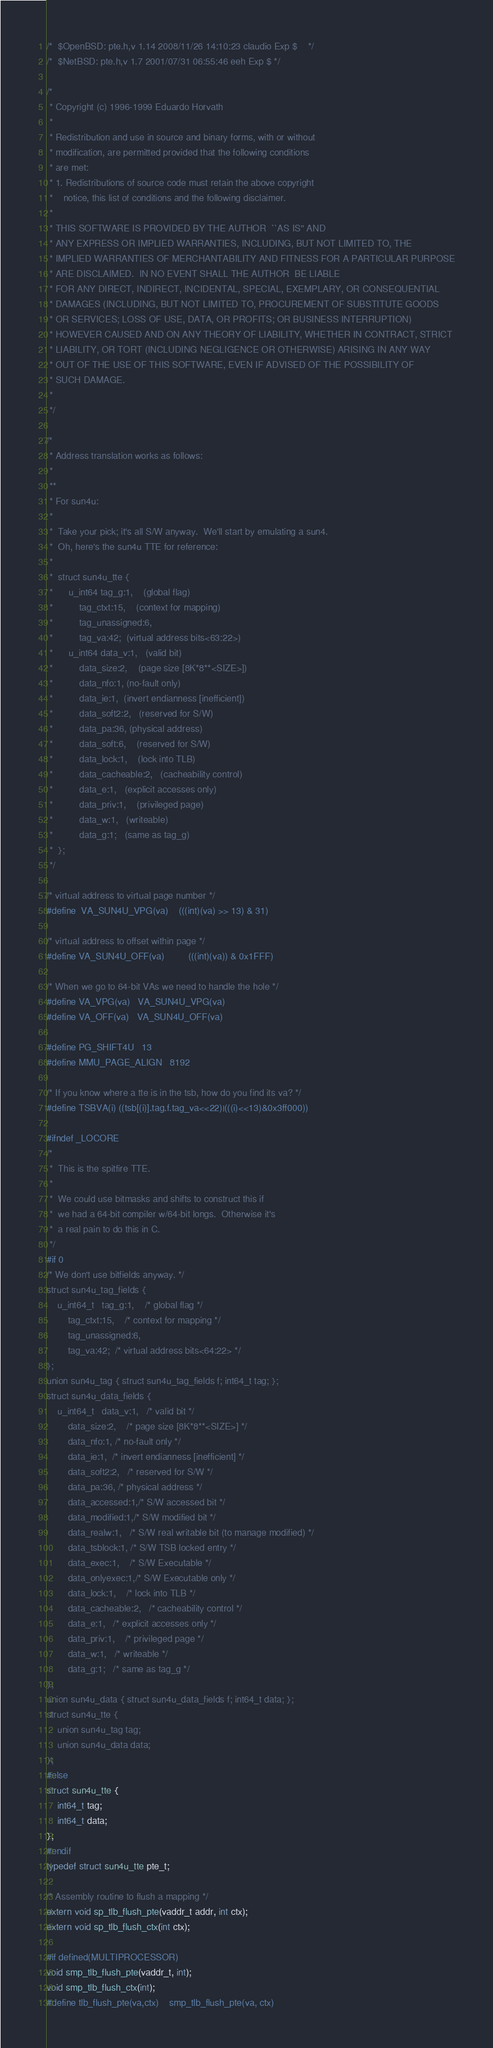Convert code to text. <code><loc_0><loc_0><loc_500><loc_500><_C_>/*	$OpenBSD: pte.h,v 1.14 2008/11/26 14:10:23 claudio Exp $	*/
/*	$NetBSD: pte.h,v 1.7 2001/07/31 06:55:46 eeh Exp $ */

/*
 * Copyright (c) 1996-1999 Eduardo Horvath
 *
 * Redistribution and use in source and binary forms, with or without
 * modification, are permitted provided that the following conditions
 * are met:
 * 1. Redistributions of source code must retain the above copyright
 *    notice, this list of conditions and the following disclaimer.
 *  
 * THIS SOFTWARE IS PROVIDED BY THE AUTHOR  ``AS IS'' AND
 * ANY EXPRESS OR IMPLIED WARRANTIES, INCLUDING, BUT NOT LIMITED TO, THE
 * IMPLIED WARRANTIES OF MERCHANTABILITY AND FITNESS FOR A PARTICULAR PURPOSE
 * ARE DISCLAIMED.  IN NO EVENT SHALL THE AUTHOR  BE LIABLE
 * FOR ANY DIRECT, INDIRECT, INCIDENTAL, SPECIAL, EXEMPLARY, OR CONSEQUENTIAL
 * DAMAGES (INCLUDING, BUT NOT LIMITED TO, PROCUREMENT OF SUBSTITUTE GOODS
 * OR SERVICES; LOSS OF USE, DATA, OR PROFITS; OR BUSINESS INTERRUPTION)
 * HOWEVER CAUSED AND ON ANY THEORY OF LIABILITY, WHETHER IN CONTRACT, STRICT
 * LIABILITY, OR TORT (INCLUDING NEGLIGENCE OR OTHERWISE) ARISING IN ANY WAY
 * OUT OF THE USE OF THIS SOFTWARE, EVEN IF ADVISED OF THE POSSIBILITY OF
 * SUCH DAMAGE.
 *
 */

/*
 * Address translation works as follows:
 *
 **
 * For sun4u:
 *	
 *	Take your pick; it's all S/W anyway.  We'll start by emulating a sun4.
 *	Oh, here's the sun4u TTE for reference:
 *
 *	struct sun4u_tte {
 *		u_int64	tag_g:1,	(global flag)
 *			tag_ctxt:15,	(context for mapping)
 *			tag_unassigned:6,
 *			tag_va:42;	(virtual address bits<63:22>)
 *		u_int64	data_v:1,	(valid bit)
 *			data_size:2,	(page size [8K*8**<SIZE>])
 *			data_nfo:1,	(no-fault only)
 *			data_ie:1,	(invert endianness [inefficient])
 *			data_soft2:2,	(reserved for S/W)
 *			data_pa:36,	(physical address)
 *			data_soft:6,	(reserved for S/W)
 *			data_lock:1,	(lock into TLB)
 *			data_cacheable:2,	(cacheability control)
 *			data_e:1,	(explicit accesses only)
 *			data_priv:1,	(privileged page)
 *			data_w:1,	(writeable)
 *			data_g:1;	(same as tag_g)
 *	};	
 */

/* virtual address to virtual page number */
#define	VA_SUN4U_VPG(va)	(((int)(va) >> 13) & 31)

/* virtual address to offset within page */
#define VA_SUN4U_OFF(va)       	(((int)(va)) & 0x1FFF)

/* When we go to 64-bit VAs we need to handle the hole */
#define VA_VPG(va)	VA_SUN4U_VPG(va)
#define VA_OFF(va)	VA_SUN4U_OFF(va)

#define PG_SHIFT4U	13
#define MMU_PAGE_ALIGN	8192

/* If you know where a tte is in the tsb, how do you find its va? */	
#define TSBVA(i)	((tsb[(i)].tag.f.tag_va<<22)|(((i)<<13)&0x3ff000))

#ifndef _LOCORE
/* 
 *  This is the spitfire TTE.
 *
 *  We could use bitmasks and shifts to construct this if
 *  we had a 64-bit compiler w/64-bit longs.  Otherwise it's
 *  a real pain to do this in C.
 */
#if 0
/* We don't use bitfields anyway. */
struct sun4u_tag_fields {
	u_int64_t	tag_g:1,	/* global flag */
		tag_ctxt:15,	/* context for mapping */
		tag_unassigned:6,
		tag_va:42;	/* virtual address bits<64:22> */
};
union sun4u_tag { struct sun4u_tag_fields f; int64_t tag; };
struct sun4u_data_fields {
	u_int64_t	data_v:1,	/* valid bit */
		data_size:2,	/* page size [8K*8**<SIZE>] */
		data_nfo:1,	/* no-fault only */
		data_ie:1,	/* invert endianness [inefficient] */
		data_soft2:2,	/* reserved for S/W */
		data_pa:36,	/* physical address */
		data_accessed:1,/* S/W accessed bit */
		data_modified:1,/* S/W modified bit */
		data_realw:1,	/* S/W real writable bit (to manage modified) */
		data_tsblock:1,	/* S/W TSB locked entry */
		data_exec:1,	/* S/W Executable */
		data_onlyexec:1,/* S/W Executable only */
		data_lock:1,	/* lock into TLB */
		data_cacheable:2,	/* cacheability control */
		data_e:1,	/* explicit accesses only */
		data_priv:1,	/* privileged page */
		data_w:1,	/* writeable */
		data_g:1;	/* same as tag_g */
};
union sun4u_data { struct sun4u_data_fields f; int64_t data; };
struct sun4u_tte {
	union sun4u_tag tag;
	union sun4u_data data;
};
#else
struct sun4u_tte {
	int64_t tag;
	int64_t data;
};
#endif
typedef struct sun4u_tte pte_t;

/* Assembly routine to flush a mapping */
extern void sp_tlb_flush_pte(vaddr_t addr, int ctx);
extern void sp_tlb_flush_ctx(int ctx);

#if defined(MULTIPROCESSOR)
void smp_tlb_flush_pte(vaddr_t, int);
void smp_tlb_flush_ctx(int);
#define tlb_flush_pte(va,ctx)	smp_tlb_flush_pte(va, ctx)</code> 